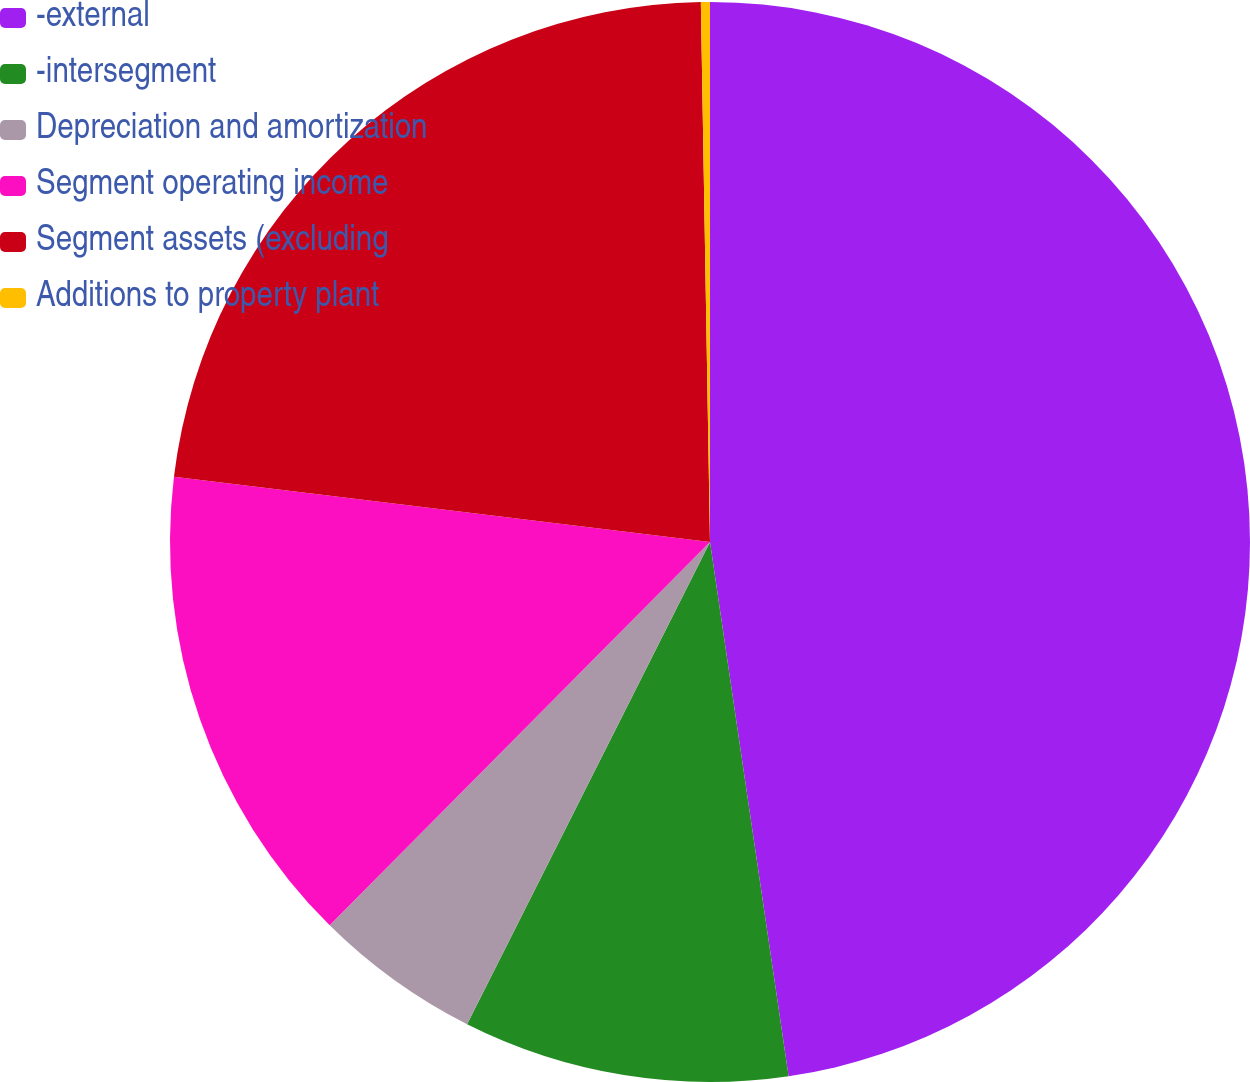Convert chart. <chart><loc_0><loc_0><loc_500><loc_500><pie_chart><fcel>-external<fcel>-intersegment<fcel>Depreciation and amortization<fcel>Segment operating income<fcel>Segment assets (excluding<fcel>Additions to property plant<nl><fcel>47.67%<fcel>9.75%<fcel>5.01%<fcel>14.49%<fcel>22.8%<fcel>0.27%<nl></chart> 